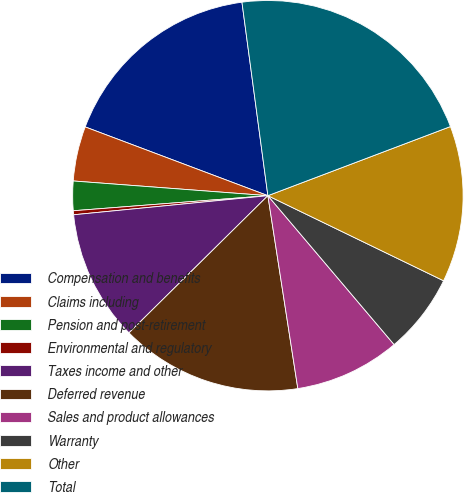Convert chart to OTSL. <chart><loc_0><loc_0><loc_500><loc_500><pie_chart><fcel>Compensation and benefits<fcel>Claims including<fcel>Pension and post-retirement<fcel>Environmental and regulatory<fcel>Taxes income and other<fcel>Deferred revenue<fcel>Sales and product allowances<fcel>Warranty<fcel>Other<fcel>Total<nl><fcel>17.15%<fcel>4.53%<fcel>2.43%<fcel>0.33%<fcel>10.84%<fcel>15.05%<fcel>8.74%<fcel>6.63%<fcel>12.94%<fcel>21.36%<nl></chart> 